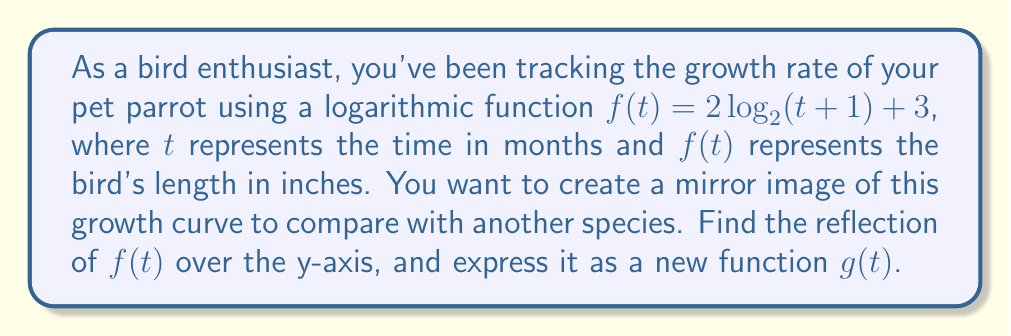Can you answer this question? To find the reflection of a function over the y-axis, we need to replace every $t$ with $-t$ in the original function. This process can be broken down into steps:

1. Start with the original function:
   $f(t) = 2\log_2(t+1) + 3$

2. Replace $t$ with $-t$:
   $g(t) = 2\log_2((-t)+1) + 3$

3. Simplify the expression inside the logarithm:
   $g(t) = 2\log_2(-t+1) + 3$

4. The domain of a logarithm must be positive, so we need to ensure $-t+1 > 0$:
   $-t+1 > 0$
   $-t > -1$
   $t < 1$

This means the domain of $g(t)$ is $(-\infty, 1)$, whereas the domain of the original function $f(t)$ was $(-1, \infty)$.

The resulting function $g(t) = 2\log_2(-t+1) + 3$ is the reflection of $f(t)$ over the y-axis. It represents a mirrored version of the parrot's growth rate, which could be used to compare with another bird species that might have an inverse growth pattern.
Answer: $g(t) = 2\log_2(-t+1) + 3$, where $t < 1$ 